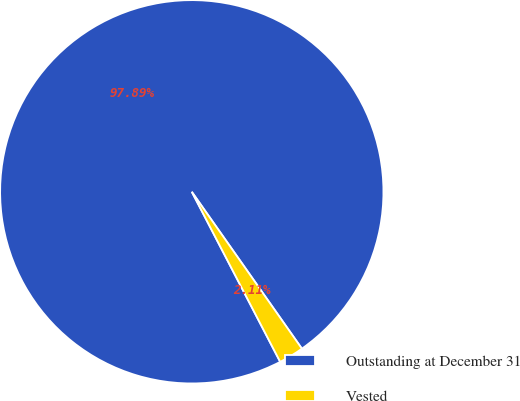Convert chart. <chart><loc_0><loc_0><loc_500><loc_500><pie_chart><fcel>Outstanding at December 31<fcel>Vested<nl><fcel>97.89%<fcel>2.11%<nl></chart> 